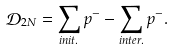Convert formula to latex. <formula><loc_0><loc_0><loc_500><loc_500>\mathcal { D } _ { 2 N } = \sum _ { i n i t . } p ^ { - } - \sum _ { i n t e r . } p ^ { - } .</formula> 